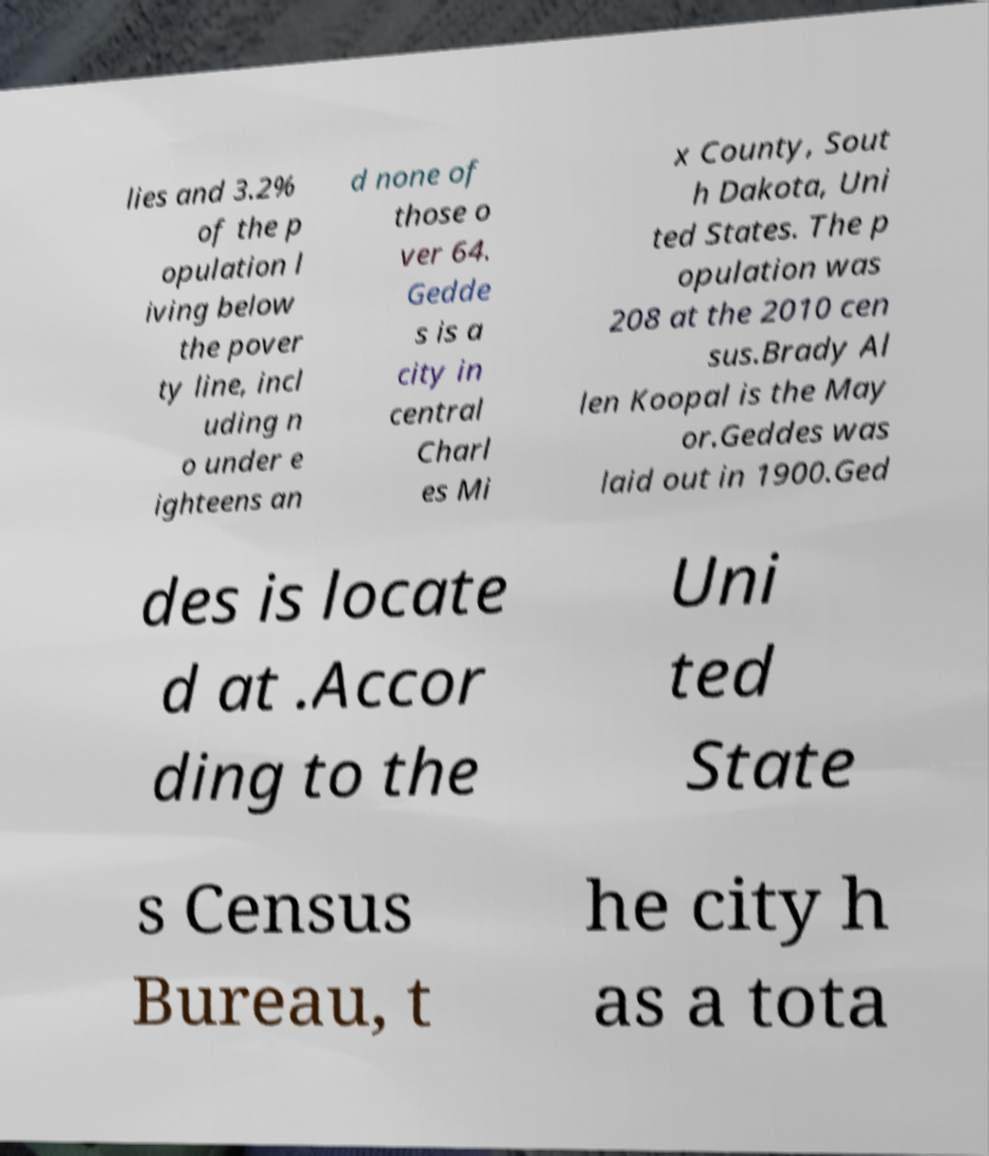Can you read and provide the text displayed in the image?This photo seems to have some interesting text. Can you extract and type it out for me? lies and 3.2% of the p opulation l iving below the pover ty line, incl uding n o under e ighteens an d none of those o ver 64. Gedde s is a city in central Charl es Mi x County, Sout h Dakota, Uni ted States. The p opulation was 208 at the 2010 cen sus.Brady Al len Koopal is the May or.Geddes was laid out in 1900.Ged des is locate d at .Accor ding to the Uni ted State s Census Bureau, t he city h as a tota 